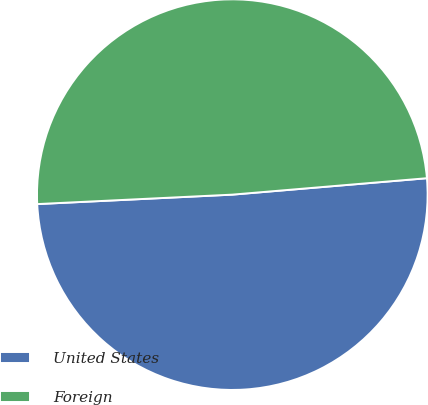Convert chart to OTSL. <chart><loc_0><loc_0><loc_500><loc_500><pie_chart><fcel>United States<fcel>Foreign<nl><fcel>50.57%<fcel>49.43%<nl></chart> 